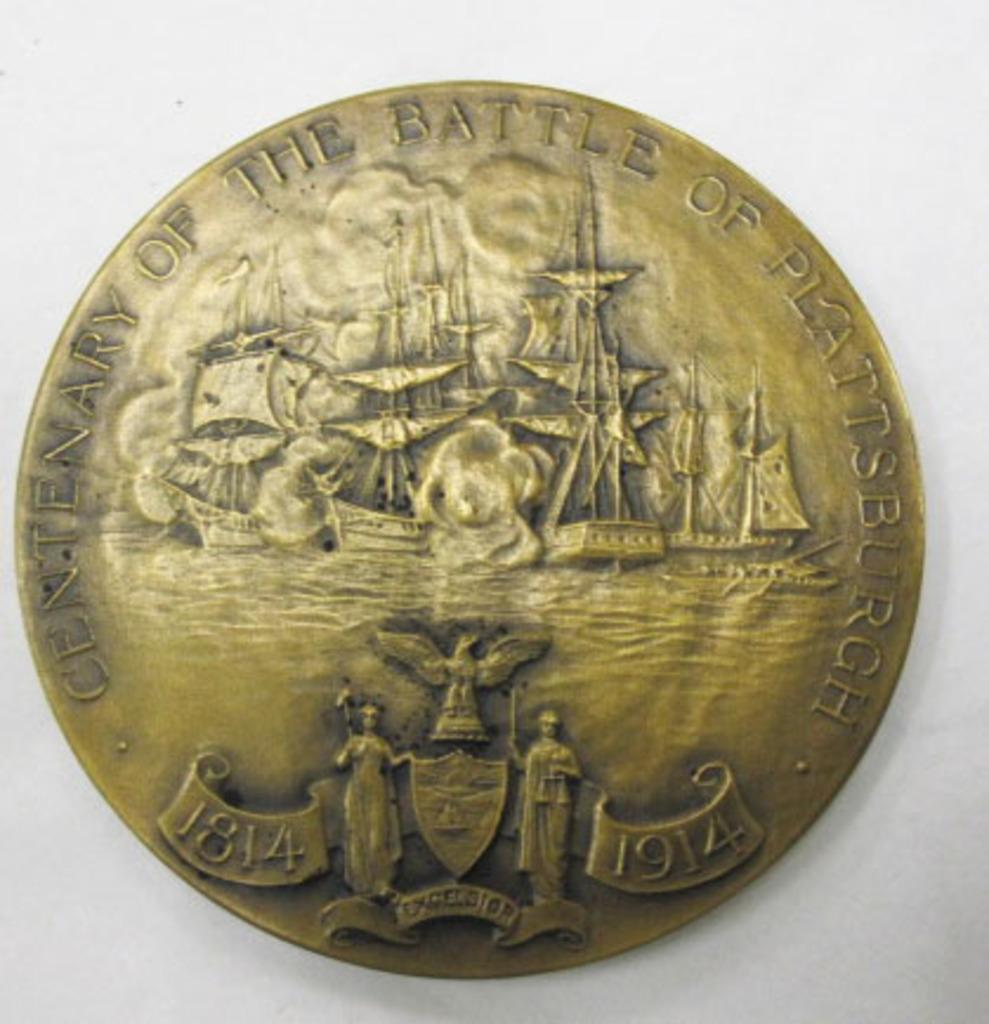<image>
Create a compact narrative representing the image presented. A coin with the dates 1814 and 1914 also shows a few ships. 